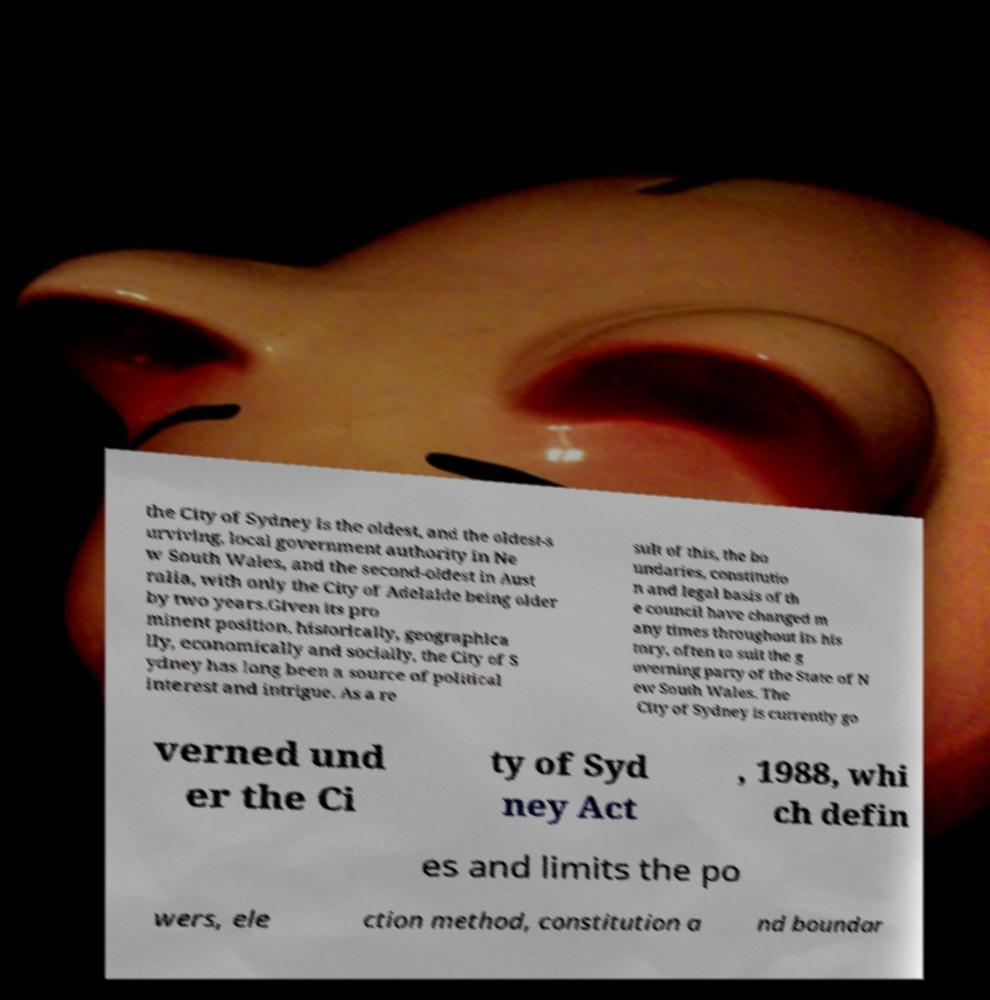What messages or text are displayed in this image? I need them in a readable, typed format. the City of Sydney is the oldest, and the oldest-s urviving, local government authority in Ne w South Wales, and the second-oldest in Aust ralia, with only the City of Adelaide being older by two years.Given its pro minent position, historically, geographica lly, economically and socially, the City of S ydney has long been a source of political interest and intrigue. As a re sult of this, the bo undaries, constitutio n and legal basis of th e council have changed m any times throughout its his tory, often to suit the g overning party of the State of N ew South Wales. The City of Sydney is currently go verned und er the Ci ty of Syd ney Act , 1988, whi ch defin es and limits the po wers, ele ction method, constitution a nd boundar 